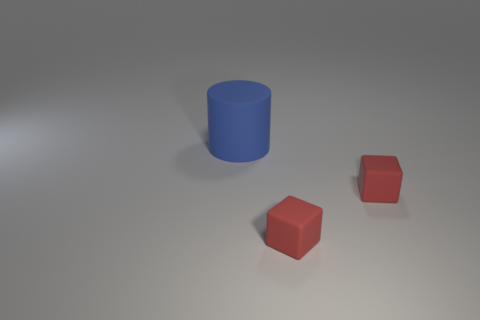Add 1 matte cubes. How many objects exist? 4 Subtract all blocks. How many objects are left? 1 Add 3 red matte blocks. How many red matte blocks are left? 5 Add 3 small blocks. How many small blocks exist? 5 Subtract 0 brown balls. How many objects are left? 3 Subtract all large brown matte things. Subtract all red blocks. How many objects are left? 1 